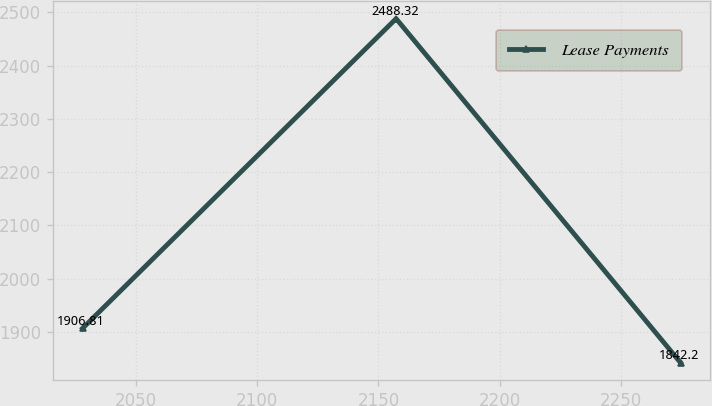Convert chart to OTSL. <chart><loc_0><loc_0><loc_500><loc_500><line_chart><ecel><fcel>Lease Payments<nl><fcel>2028.18<fcel>1906.81<nl><fcel>2157.29<fcel>2488.32<nl><fcel>2274.4<fcel>1842.2<nl></chart> 